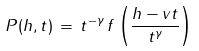Convert formula to latex. <formula><loc_0><loc_0><loc_500><loc_500>P ( h , t ) \, = \, t ^ { - \gamma } \, f \left ( \frac { h - v t } { t ^ { \gamma } } \right )</formula> 